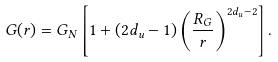<formula> <loc_0><loc_0><loc_500><loc_500>G ( r ) = G _ { N } \left [ 1 + ( 2 d _ { u } - 1 ) \left ( \frac { R _ { G } } { r } \right ) ^ { 2 d _ { u } - 2 } \right ] .</formula> 